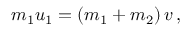Convert formula to latex. <formula><loc_0><loc_0><loc_500><loc_500>m _ { 1 } u _ { 1 } = \left ( m _ { 1 } + m _ { 2 } \right ) v \, ,</formula> 